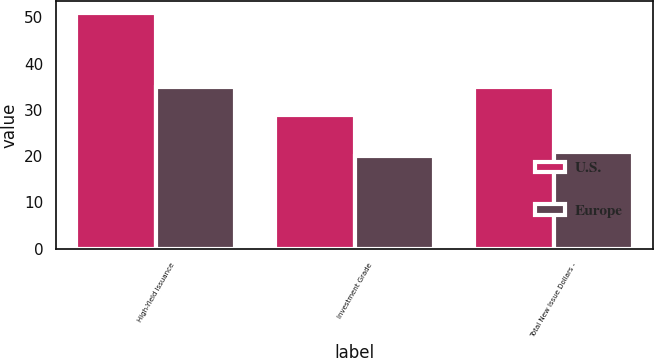<chart> <loc_0><loc_0><loc_500><loc_500><stacked_bar_chart><ecel><fcel>High-Yield Issuance<fcel>Investment Grade<fcel>Total New Issue Dollars -<nl><fcel>U.S.<fcel>51<fcel>29<fcel>35<nl><fcel>Europe<fcel>35<fcel>20<fcel>21<nl></chart> 